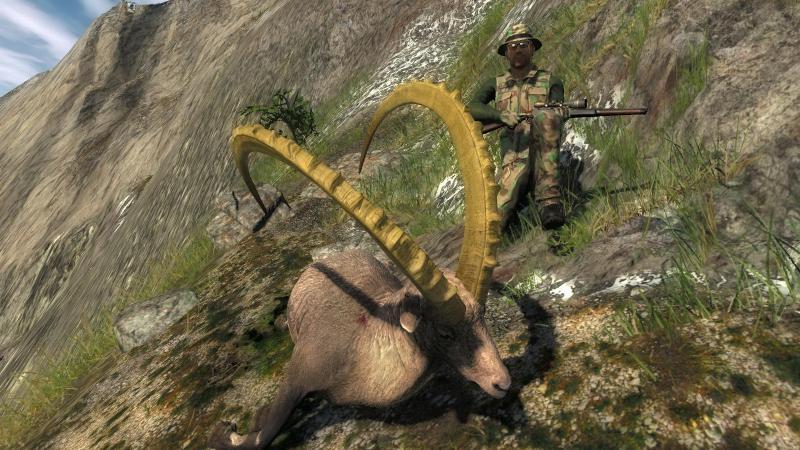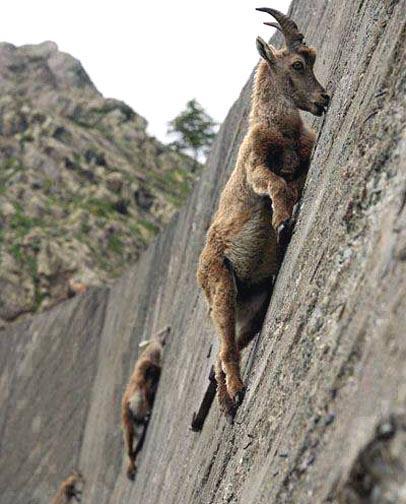The first image is the image on the left, the second image is the image on the right. For the images displayed, is the sentence "Left image shows exactly one horned animal, with both horns showing clearly and separately." factually correct? Answer yes or no. Yes. The first image is the image on the left, the second image is the image on the right. Analyze the images presented: Is the assertion "the animals in the image on the right are on a steep hillside." valid? Answer yes or no. Yes. 